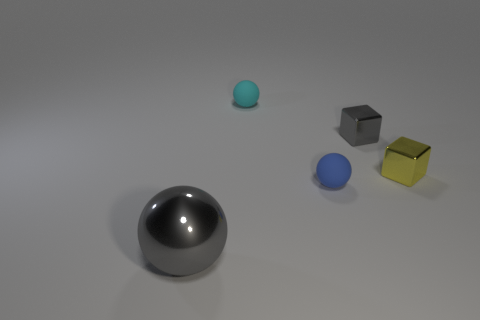There is a small blue thing; are there any small blue things left of it?
Your answer should be very brief. No. There is a sphere that is behind the gray thing right of the tiny blue matte object; what is its material?
Offer a very short reply. Rubber. There is a yellow shiny object that is the same shape as the tiny gray thing; what size is it?
Provide a succinct answer. Small. What is the color of the tiny object that is both left of the gray metal block and to the right of the tiny cyan matte sphere?
Give a very brief answer. Blue. Is the size of the gray thing that is to the right of the cyan rubber ball the same as the cyan matte thing?
Keep it short and to the point. Yes. Is the material of the cyan thing the same as the gray object that is right of the large sphere?
Your response must be concise. No. How many cyan objects are big metallic spheres or small objects?
Offer a very short reply. 1. Are any purple metal spheres visible?
Provide a short and direct response. No. Is there a small shiny object in front of the gray metallic thing that is on the right side of the gray object that is to the left of the cyan object?
Offer a very short reply. Yes. Is there any other thing that has the same size as the gray sphere?
Provide a succinct answer. No. 